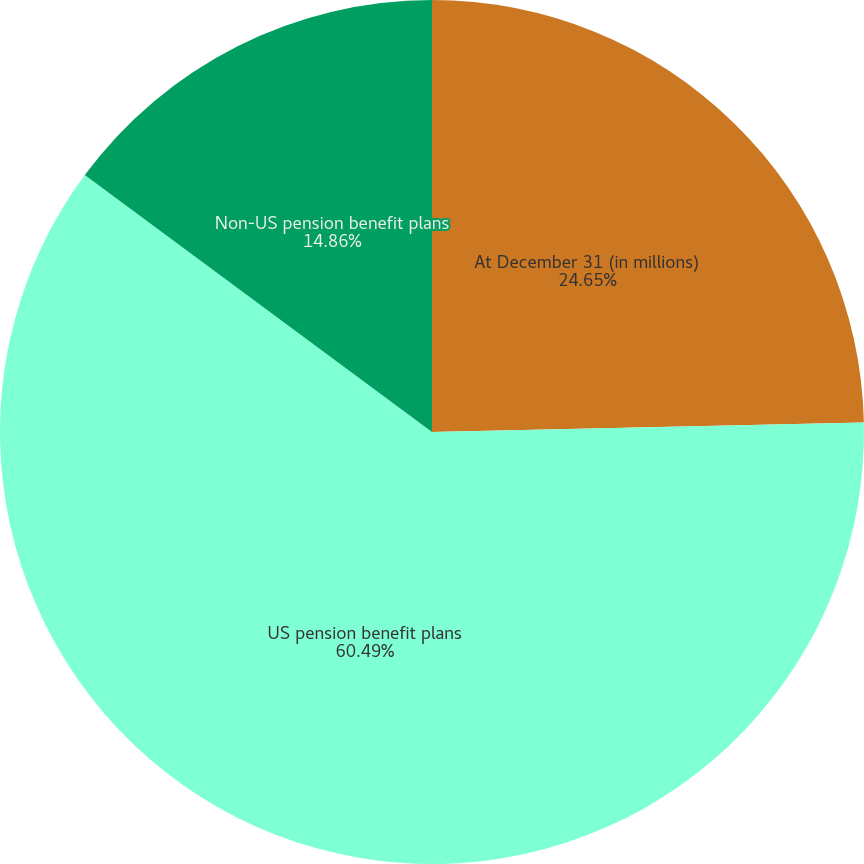Convert chart to OTSL. <chart><loc_0><loc_0><loc_500><loc_500><pie_chart><fcel>At December 31 (in millions)<fcel>US pension benefit plans<fcel>Non-US pension benefit plans<nl><fcel>24.65%<fcel>60.5%<fcel>14.86%<nl></chart> 